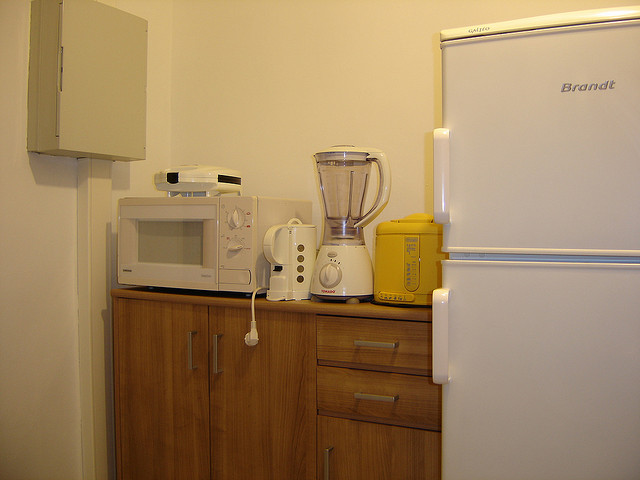Extract all visible text content from this image. Brantd 